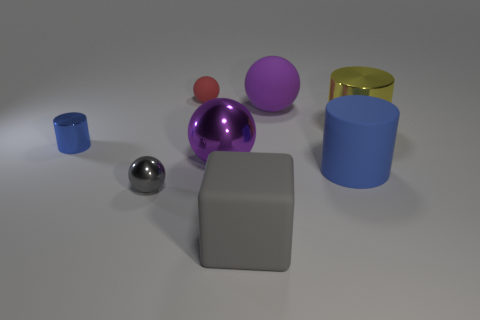What materials do the objects in the image seem to be made of? The objects appear to be made of various materials. The small cylinder looks metallic, the tiny red sphere seems like rubber, the large purple sphere might be plastic, and both the yellow and blue cylinders could be matte-painted metal or plastic. 